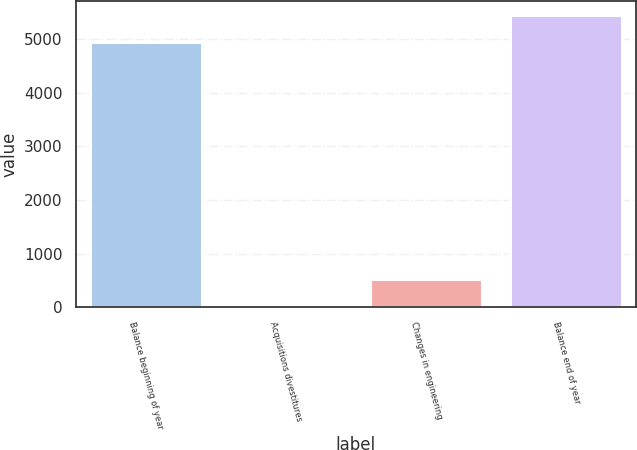Convert chart. <chart><loc_0><loc_0><loc_500><loc_500><bar_chart><fcel>Balance beginning of year<fcel>Acquisitions divestitures<fcel>Changes in engineering<fcel>Balance end of year<nl><fcel>4935<fcel>36<fcel>535.6<fcel>5434.6<nl></chart> 